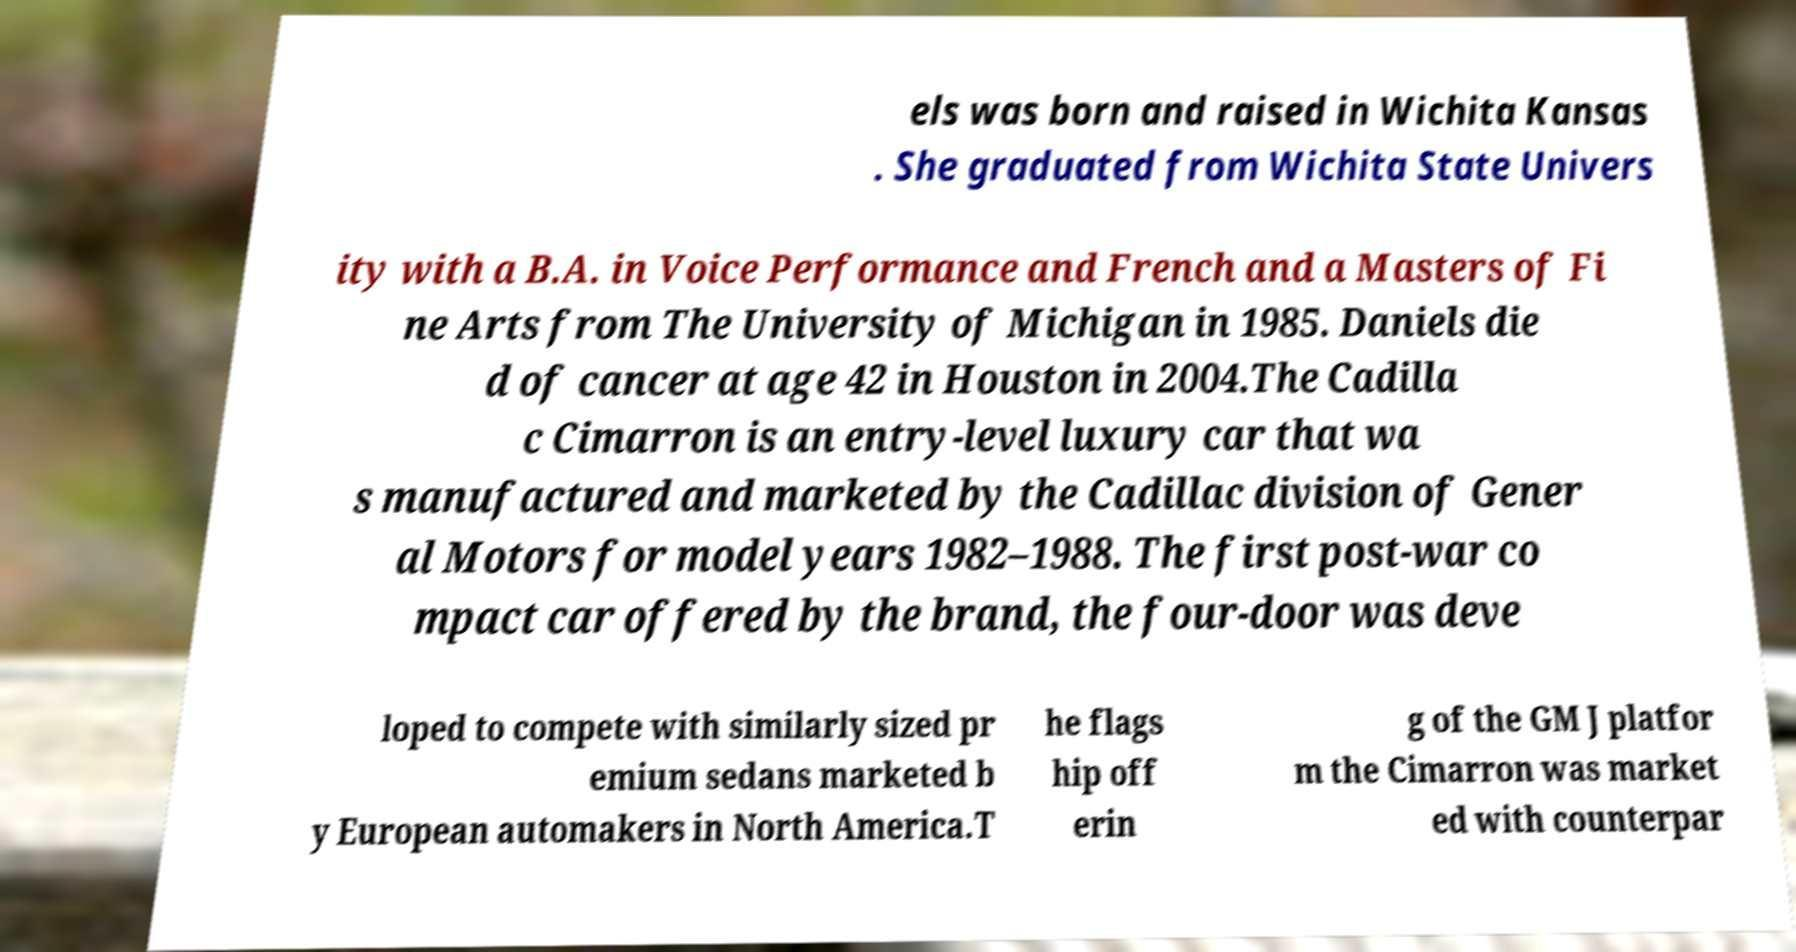Please identify and transcribe the text found in this image. els was born and raised in Wichita Kansas . She graduated from Wichita State Univers ity with a B.A. in Voice Performance and French and a Masters of Fi ne Arts from The University of Michigan in 1985. Daniels die d of cancer at age 42 in Houston in 2004.The Cadilla c Cimarron is an entry-level luxury car that wa s manufactured and marketed by the Cadillac division of Gener al Motors for model years 1982–1988. The first post-war co mpact car offered by the brand, the four-door was deve loped to compete with similarly sized pr emium sedans marketed b y European automakers in North America.T he flags hip off erin g of the GM J platfor m the Cimarron was market ed with counterpar 